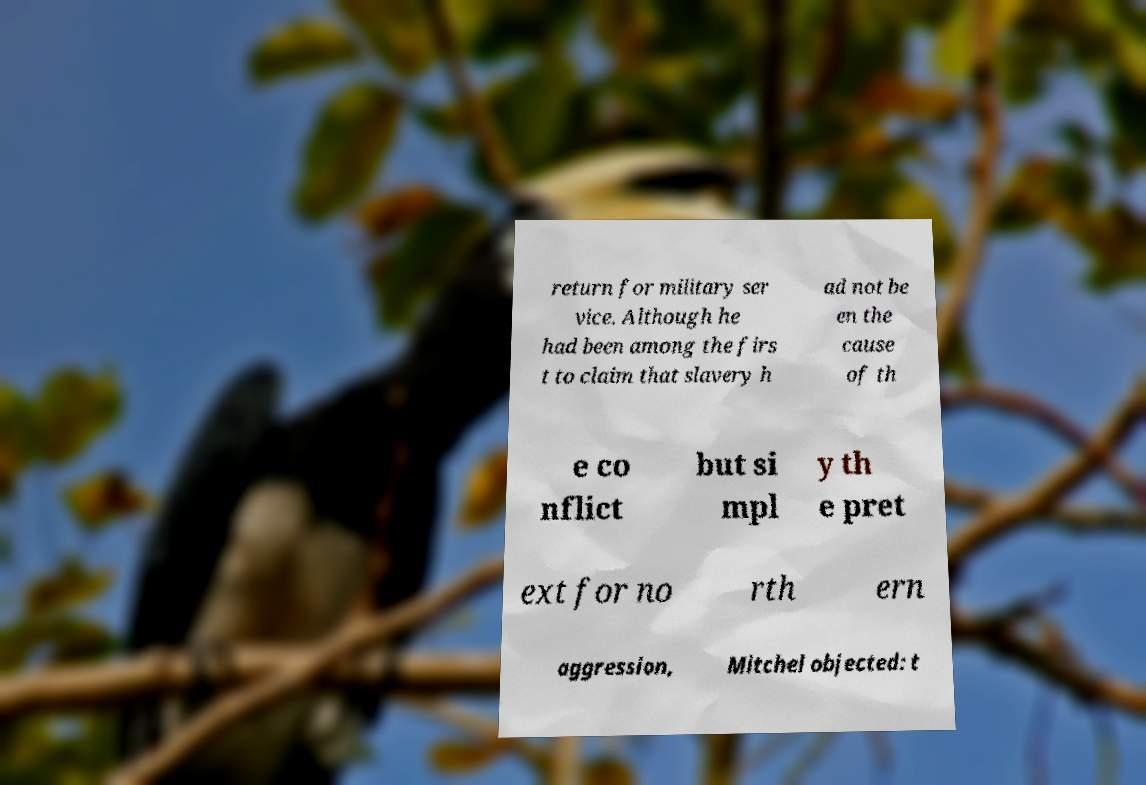There's text embedded in this image that I need extracted. Can you transcribe it verbatim? return for military ser vice. Although he had been among the firs t to claim that slavery h ad not be en the cause of th e co nflict but si mpl y th e pret ext for no rth ern aggression, Mitchel objected: t 